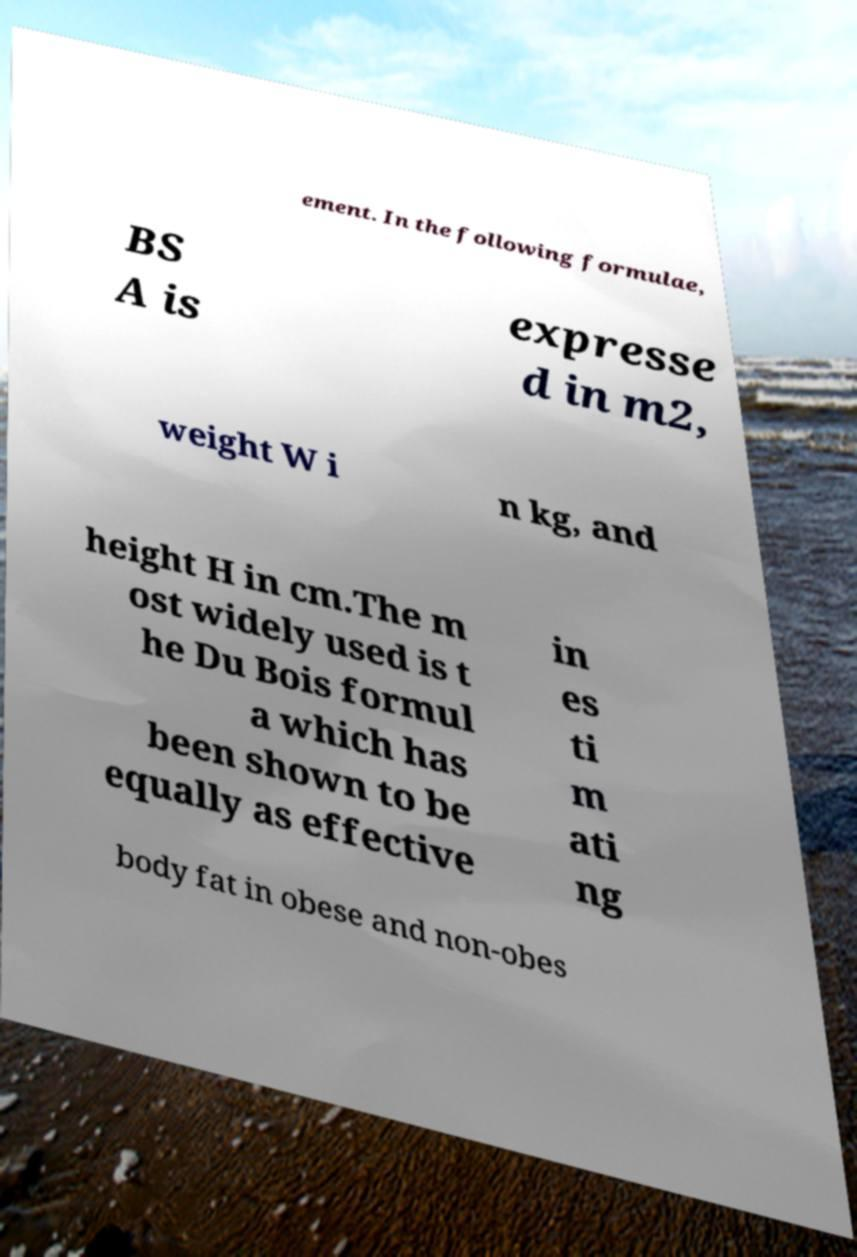Can you read and provide the text displayed in the image?This photo seems to have some interesting text. Can you extract and type it out for me? ement. In the following formulae, BS A is expresse d in m2, weight W i n kg, and height H in cm.The m ost widely used is t he Du Bois formul a which has been shown to be equally as effective in es ti m ati ng body fat in obese and non-obes 